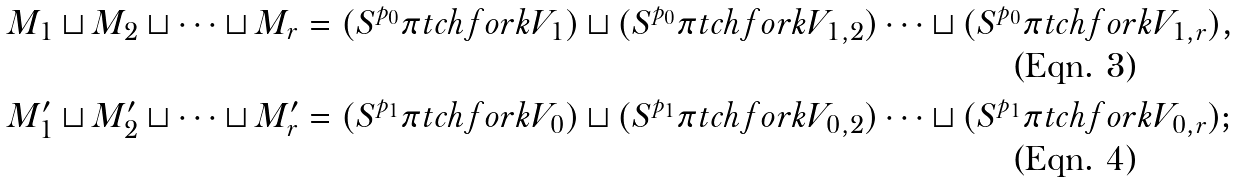Convert formula to latex. <formula><loc_0><loc_0><loc_500><loc_500>M _ { 1 } \sqcup M _ { 2 } \sqcup \cdots \sqcup M _ { r } & = ( S ^ { p _ { 0 } } \pi t c h f o r k V _ { 1 } ) \sqcup ( S ^ { p _ { 0 } } \pi t c h f o r k V _ { 1 , 2 } ) \cdots \sqcup ( S ^ { p _ { 0 } } \pi t c h f o r k V _ { 1 , r } ) , \\ M ^ { \prime } _ { 1 } \sqcup M ^ { \prime } _ { 2 } \sqcup \cdots \sqcup M ^ { \prime } _ { r } & = ( S ^ { p _ { 1 } } \pi t c h f o r k V _ { 0 } ) \sqcup ( S ^ { p _ { 1 } } \pi t c h f o r k V _ { 0 , 2 } ) \cdots \sqcup ( S ^ { p _ { 1 } } \pi t c h f o r k V _ { 0 , r } ) ;</formula> 